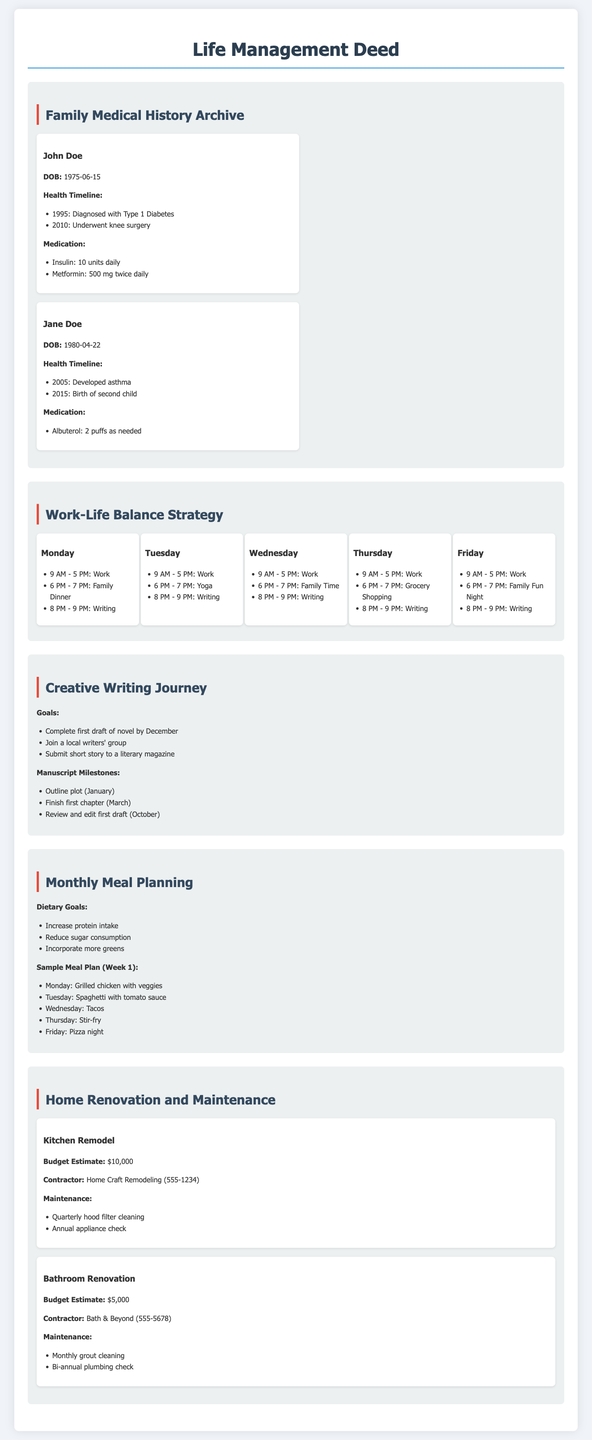What is John Doe's date of birth? The document lists John Doe's date of birth, which is provided under his profile.
Answer: 1975-06-15 How many children does Jane Doe have? The health timeline for Jane Doe mentions the birth of her second child, indicating she has two children.
Answer: 2 What are the dietary goals outlined in the meal planning section? The document specifies three dietary goals under the monthly meal planning section.
Answer: Increase protein intake, reduce sugar consumption, incorporate more greens What is the budget estimate for the kitchen remodel? The document provides a budget estimate for the kitchen remodel project.
Answer: $10,000 How many writing sessions are scheduled on Fridays? The work-life balance strategy shows scheduled activities on Fridays, indicating the number of writing sessions.
Answer: 1 Who is the contractor for the bathroom renovation? The document lists the contractor for the bathroom renovation project, providing specific contractor details.
Answer: Bath & Beyond What is the first task in John Doe's health timeline? The health timeline includes various events but the first task is explicitly stated.
Answer: Diagnosed with Type 1 Diabetes What is the submission timeline for the first draft of the novel? The creative writing journey tracker includes a specific deadline for the first draft of the novel.
Answer: December What type of project is the focus of the section titled "Home Renovation and Maintenance"? This section identifies specific projects related to home improvement.
Answer: Kitchen Remodel, Bathroom Renovation 